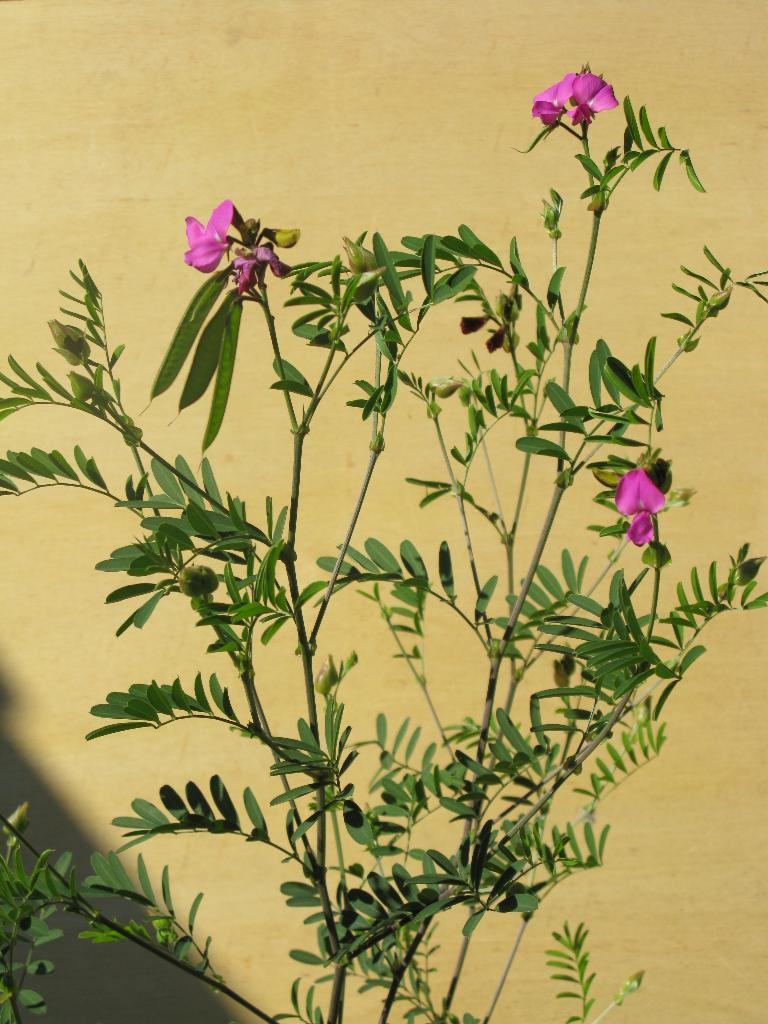What is present in the image? There is a plant in the image. What can be observed about the plant? The plant has flowers. What is the color of the flowers? The flowers are pink in color. What can be seen in the background of the image? There is a wall in the background of the image. What is the color of the wall? The wall is cream in color. What type of cloth is being used to tell a story in the image? There is no cloth or storytelling activity present in the image; it features a plant with pink flowers and a cream-colored wall in the background. 